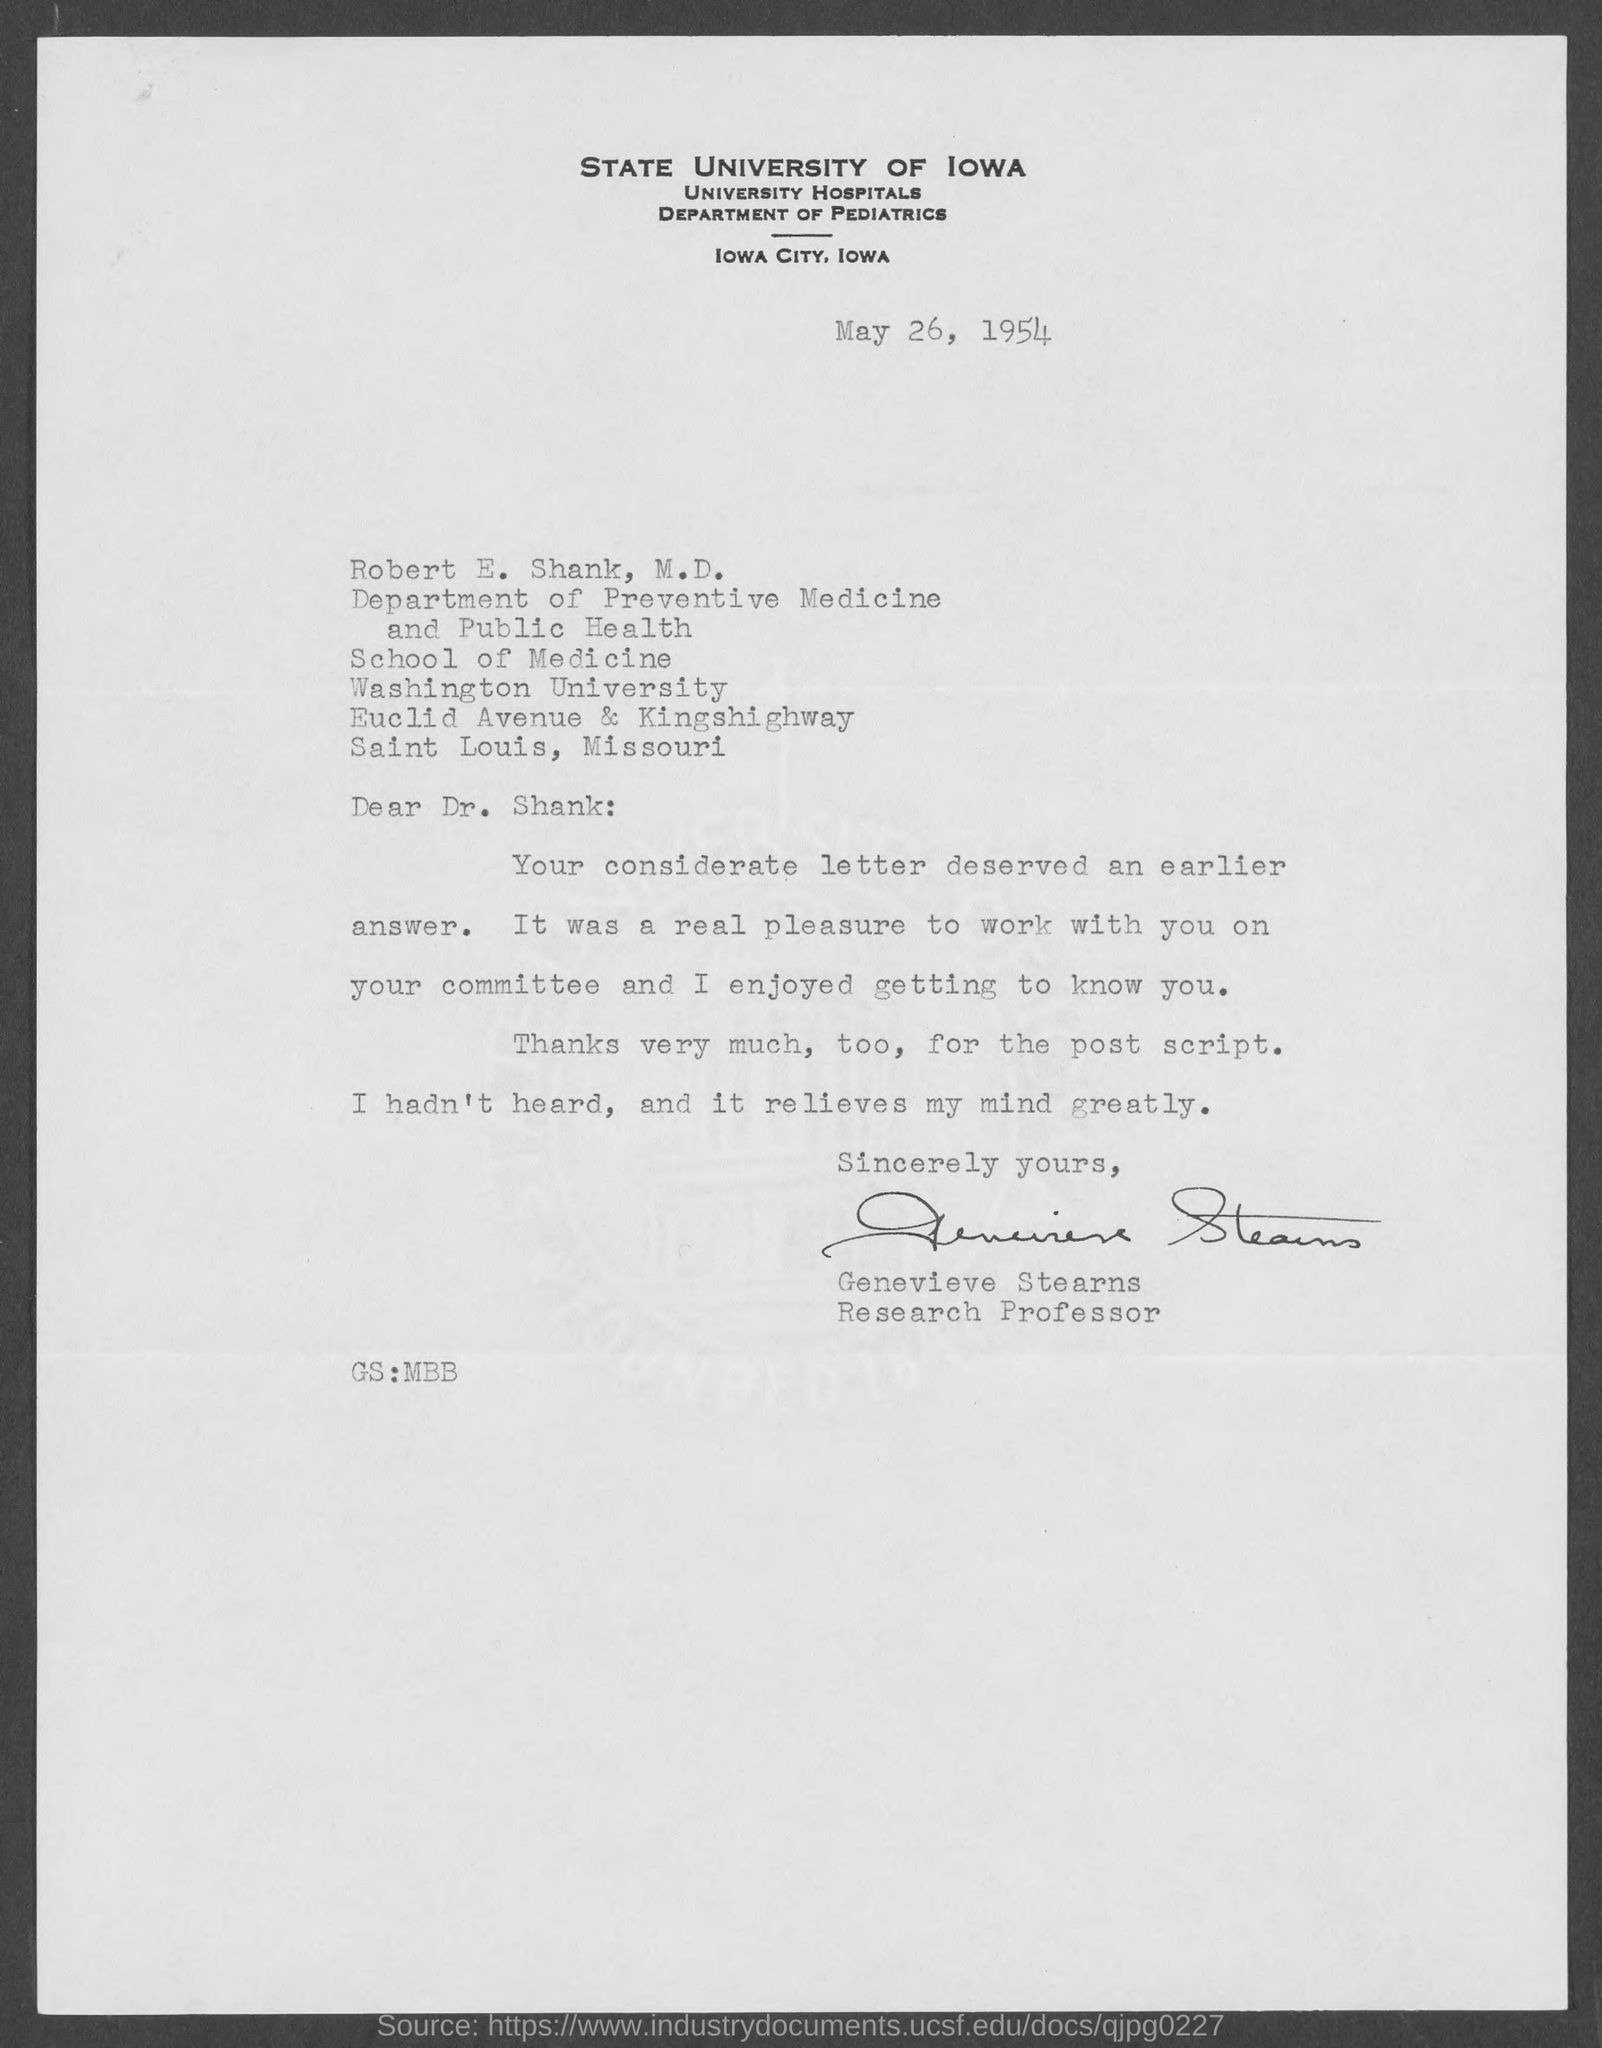Highlight a few significant elements in this photo. The memorandum is dated on May 26, 1954. 